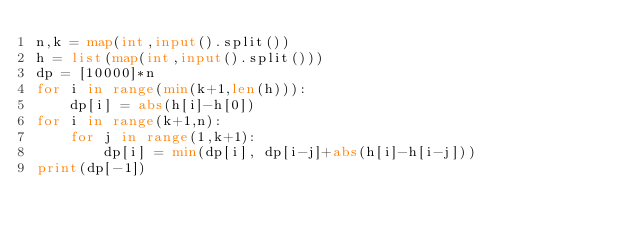<code> <loc_0><loc_0><loc_500><loc_500><_Python_>n,k = map(int,input().split())
h = list(map(int,input().split()))
dp = [10000]*n
for i in range(min(k+1,len(h))):
    dp[i] = abs(h[i]-h[0])
for i in range(k+1,n):
    for j in range(1,k+1):
        dp[i] = min(dp[i], dp[i-j]+abs(h[i]-h[i-j]))
print(dp[-1])</code> 